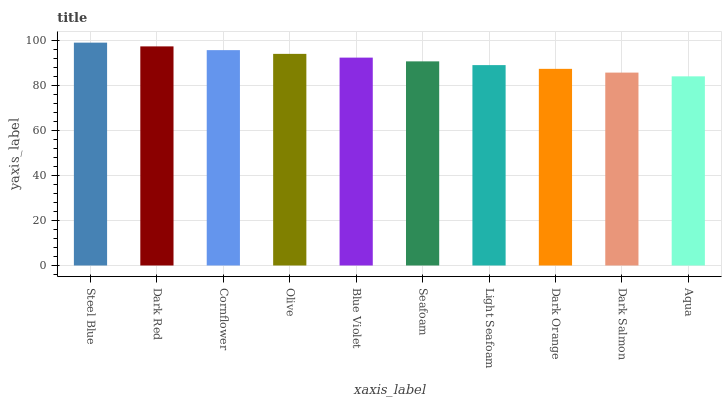Is Aqua the minimum?
Answer yes or no. Yes. Is Steel Blue the maximum?
Answer yes or no. Yes. Is Dark Red the minimum?
Answer yes or no. No. Is Dark Red the maximum?
Answer yes or no. No. Is Steel Blue greater than Dark Red?
Answer yes or no. Yes. Is Dark Red less than Steel Blue?
Answer yes or no. Yes. Is Dark Red greater than Steel Blue?
Answer yes or no. No. Is Steel Blue less than Dark Red?
Answer yes or no. No. Is Blue Violet the high median?
Answer yes or no. Yes. Is Seafoam the low median?
Answer yes or no. Yes. Is Steel Blue the high median?
Answer yes or no. No. Is Dark Salmon the low median?
Answer yes or no. No. 